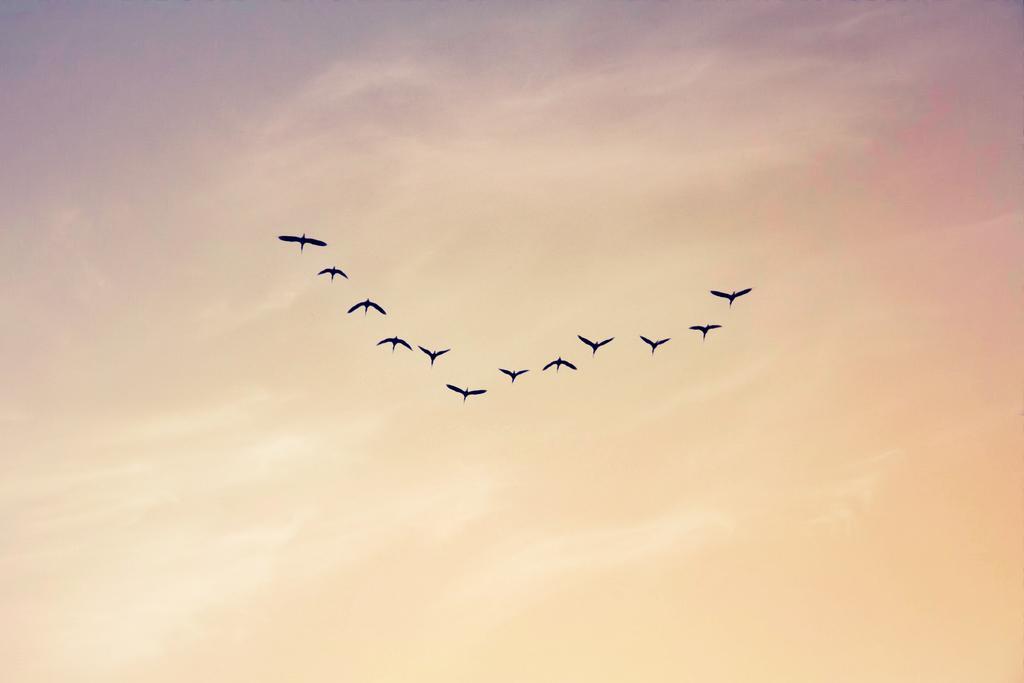How would you summarize this image in a sentence or two? In this picture I can observe some birds flying in the sky. In the background there is a sky. The sky is in yellow color. 